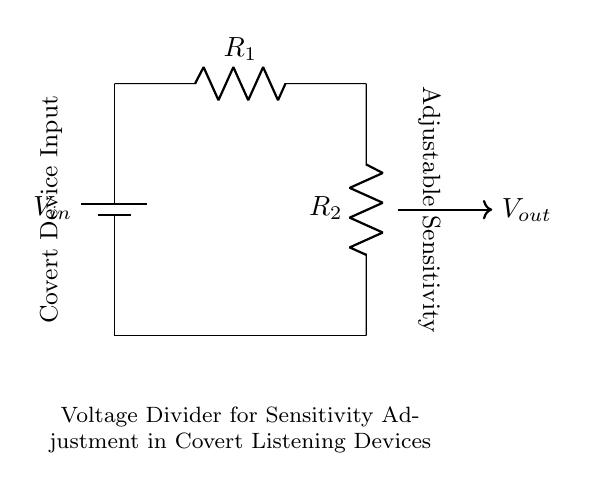What is the input voltage labeled in the circuit? The input voltage is labeled as \( V_{in} \) in the diagram, which is typically the source voltage supplied to the circuit.
Answer: \( V_{in} \) What type of circuit is displayed? The circuit is identified as a voltage divider, which utilizes two resistors to divide the input voltage.
Answer: Voltage divider How many resistors are present in the circuit? The circuit contains two resistors, denoted as \( R_1 \) and \( R_2 \).
Answer: 2 What is the function of \( V_{out} \) in the circuit? \( V_{out} \) represents the output voltage which is adjustable based on the resistance values of \( R_1 \) and \( R_2 \).
Answer: Adjustable voltage If \( R_1 \) is increased, what happens to \( V_{out} \)? Increasing \( R_1 \) raises the total resistance in the voltage divider, leading to a decrease in \( V_{out} \).
Answer: Decreases What happens to the sensitivity of the covert listening device when \( R_2 \) is decreased? Decreasing \( R_2 \) will increase \( V_{out} \), thus enhancing the sensitivity of the covert listening device.
Answer: Increases sensitivity What is the purpose of the voltage divider in covert listening devices? The voltage divider is used to adjust the output voltage, thereby controlling the sensitivity of the listening device based on different operational conditions.
Answer: Sensitivity adjustment 